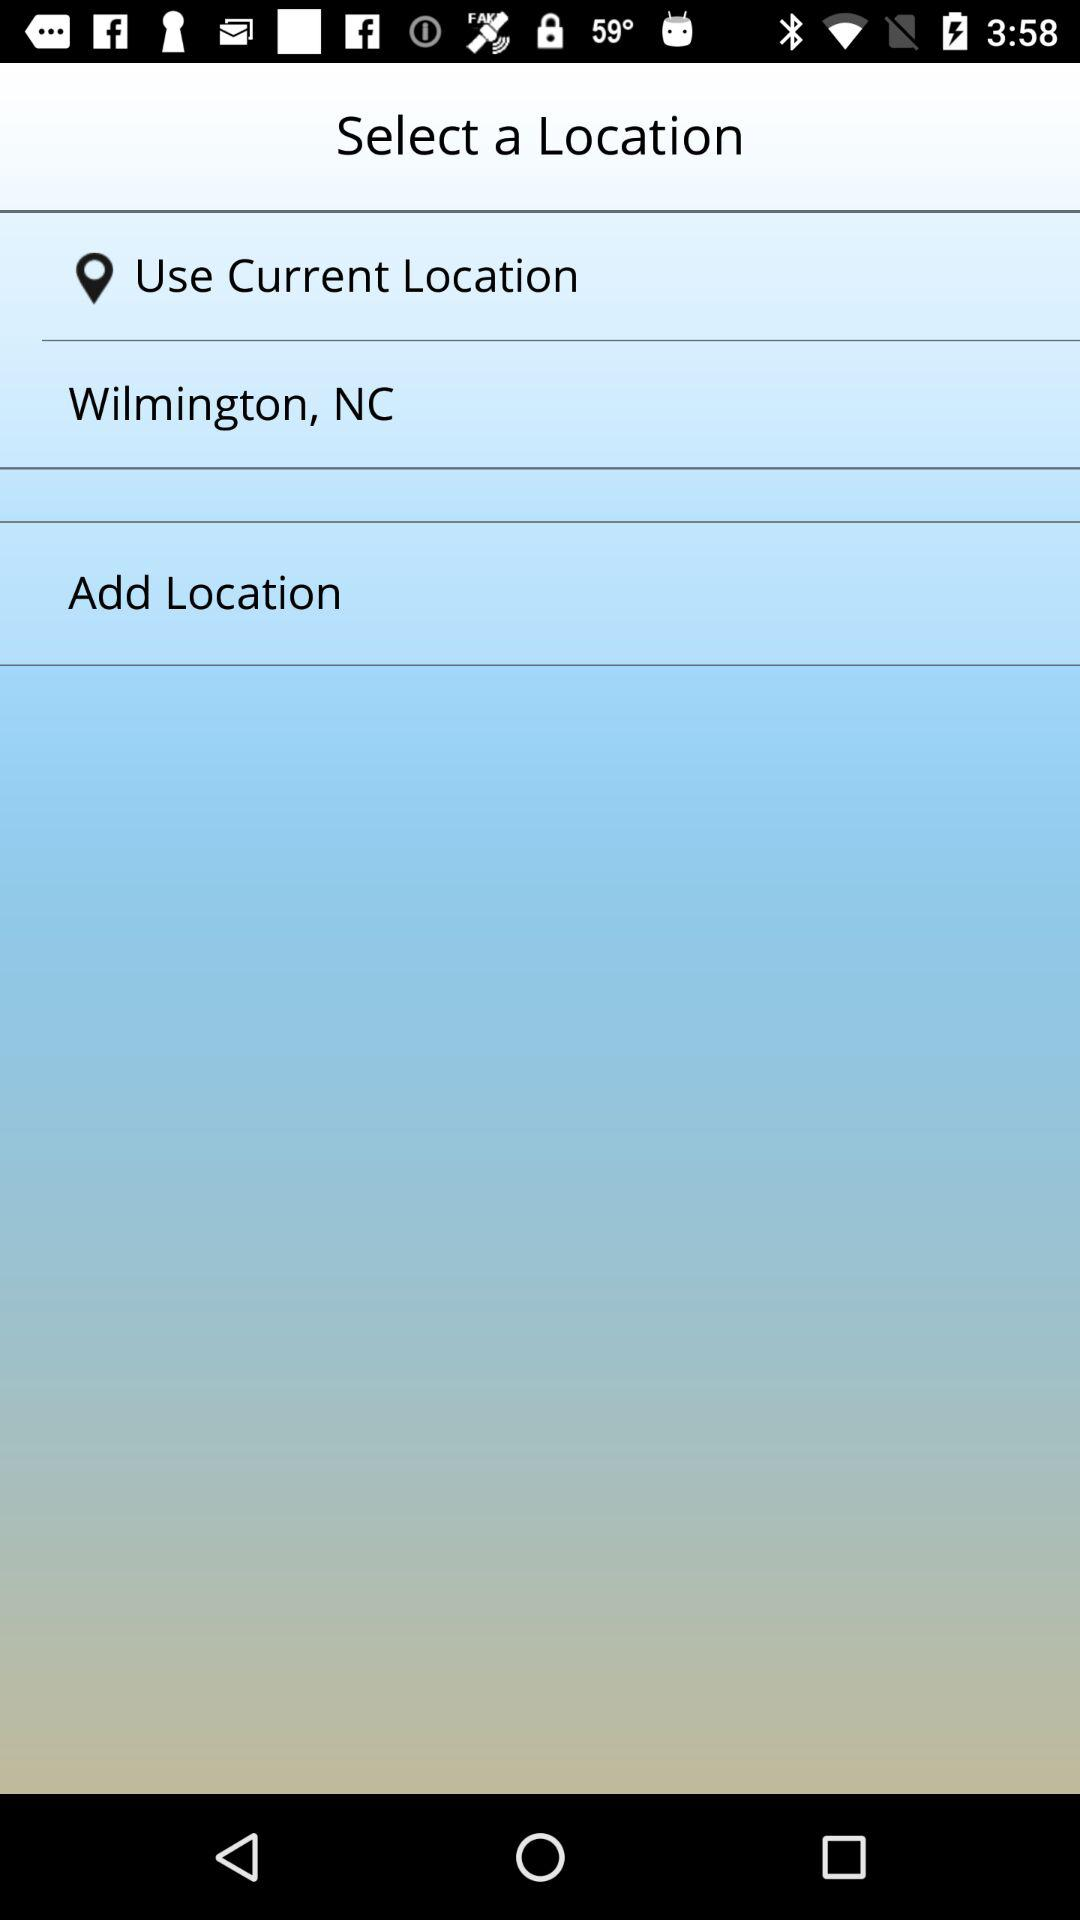What is the mentioned location? The mentioned location is Wilmington, NC. 